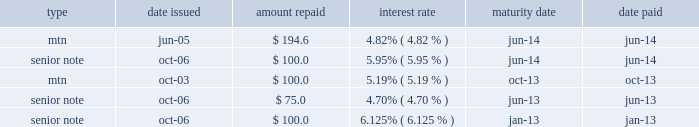Kimco realty corporation and subsidiaries notes to consolidated financial statements , continued senior unsecured notes / medium term notes 2013 during september 2009 , the company entered into a fifth supplemental indenture , under the indenture governing its medium term notes ( 201cmtn 201d ) and senior notes , which included the financial covenants for future offerings under the indenture that were removed by the fourth supplemental indenture .
In accordance with the terms of the indenture , as amended , pursuant to which the company 2019s senior unsecured notes , except for $ 300.0 million issued during april 2007 under the fourth supplemental indenture , have been issued , the company is subject to maintaining ( a ) certain maximum leverage ratios on both unsecured senior corporate and secured debt , minimum debt service coverage ratios and minimum equity levels , ( b ) certain debt service ratios , ( c ) certain asset to debt ratios and ( d ) restricted from paying dividends in amounts that exceed by more than $ 26.0 million the funds from operations , as defined , generated through the end of the calendar quarter most recently completed prior to the declaration of such dividend ; however , this dividend limitation does not apply to any distributions necessary to maintain the company 2019s qualification as a reit providing the company is in compliance with its total leverage limitations .
The company had a mtn program pursuant to which it offered for sale its senior unsecured debt for any general corporate purposes , including ( i ) funding specific liquidity requirements in its business , including property acquisitions , development and redevelopment costs and ( ii ) managing the company 2019s debt maturities .
Interest on the company 2019s fixed-rate senior unsecured notes and medium term notes is payable semi-annually in arrears .
Proceeds from these issuances were primarily used for the acquisition of neighborhood and community shopping centers , the expansion and improvement of properties in the company 2019s portfolio and the repayment of certain debt obligations of the company .
During april 2014 , the company issued $ 500.0 million of 7-year senior unsecured notes at an interest rate of 3.20% ( 3.20 % ) payable semi-annually in arrears which are scheduled to mature in may 2021 .
The company used the net proceeds from this issuance of $ 495.4 million , after deducting the underwriting discount and offering expenses , for general corporate purposes including reducing borrowings under the company 2019s revolving credit facility and repayment of maturing debt .
In connection with this issuance , the company entered into a seventh supplemental indenture which , among other things , revised , for all securities created on or after the date of the seventh supplemental indenture , the definition of unencumbered total asset value , used to determine compliance with certain covenants within the indenture .
During may 2013 , the company issued $ 350.0 million of 10-year senior unsecured notes at an interest rate of 3.125% ( 3.125 % ) payable semi-annually in arrears which are scheduled to mature in june 2023 .
Net proceeds from the issuance were $ 344.7 million , after related transaction costs of $ 0.5 million .
The proceeds from this issuance were used for general corporate purposes including the partial reduction of borrowings under the company 2019s revolving credit facility and the repayment of $ 75.0 million senior unsecured notes which matured in june 2013 .
During july 2013 , a wholly-owned subsidiary of the company issued $ 200.0 million canadian denominated ( 201ccad 201d ) series 4 unsecured notes on a private placement basis in canada .
The notes bear interest at 3.855% ( 3.855 % ) and are scheduled to mature on august 4 , 2020 .
Proceeds from the notes were used to repay the company 2019s cad $ 200.0 million 5.180% ( 5.180 % ) unsecured notes , which matured on august 16 , 2013 .
During the years ended december 31 , 2014 and 2013 , the company repaid the following notes ( dollars in millions ) : type date issued amount repaid interest rate maturity date date paid .

For years ended dec 31 , 2013 and dec 31 , 2014 , how much did the company repay , in millions , to mtn? 
Computations: (194.6 + 100)
Answer: 294.6. 